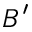<formula> <loc_0><loc_0><loc_500><loc_500>B ^ { \prime }</formula> 